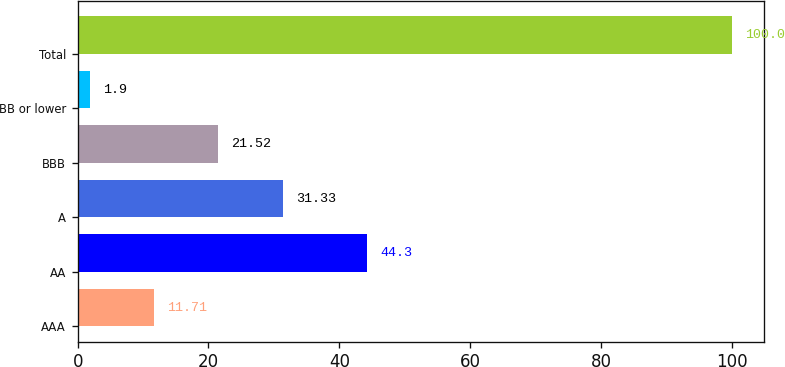<chart> <loc_0><loc_0><loc_500><loc_500><bar_chart><fcel>AAA<fcel>AA<fcel>A<fcel>BBB<fcel>BB or lower<fcel>Total<nl><fcel>11.71<fcel>44.3<fcel>31.33<fcel>21.52<fcel>1.9<fcel>100<nl></chart> 